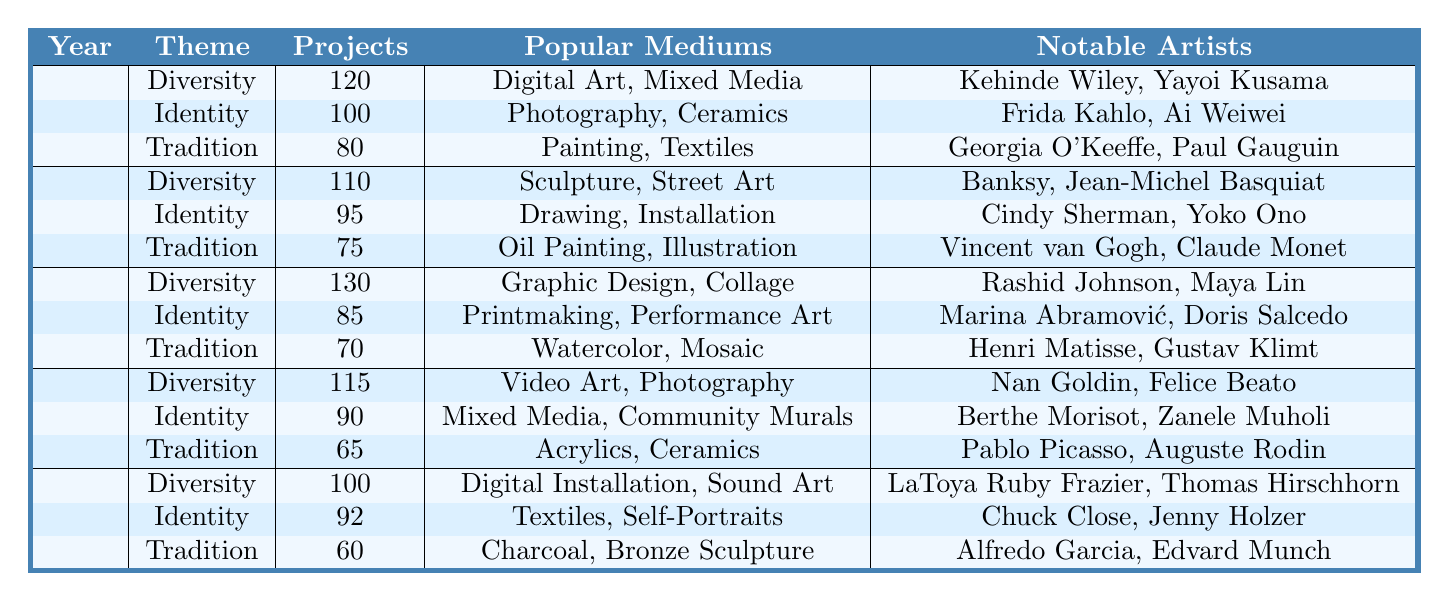What cultural theme had the most projects in 2023? In 2023, the table shows that the Diversity theme has 120 projects, which is more than Identity (100) and Tradition (80).
Answer: Diversity What is the total number of projects dedicated to the Identity theme from 2019 to 2023? Summing the Identity projects over the years: 92 (2019) + 90 (2020) + 85 (2021) + 95 (2022) + 100 (2023) = 462.
Answer: 462 Was there an increase in the number of Diversity projects from 2019 to 2023? In 2019, there were 100 Diversity projects, and in 2023, there were 120 projects. Since 120 is greater than 100, there was an increase.
Answer: Yes Which year had the least number of Tradition projects? Looking at the Tradition projects data, we see 60 (2019), 65 (2020), 70 (2021), 75 (2022), and 80 (2023). The least is 60 in 2019.
Answer: 2019 What was the average number of projects for the Tradition theme over the last five years? The total for Tradition projects is 60 + 65 + 70 + 75 + 80 = 350. There are 5 years, so the average is 350/5 = 70.
Answer: 70 How many more projects did the Diversity theme have than the Tradition theme in 2021? In 2021, Diversity had 130 projects and Tradition had 70 projects. The difference is 130 - 70 = 60.
Answer: 60 Which mediums were popular for Identity projects in 2022? The table indicates that in 2022, the popular mediums for Identity projects were Drawing and Installation.
Answer: Drawing, Installation What notable artists were featured in Diversity projects in 2020? According to the table, the notable artists for Diversity projects in 2020 were Nan Goldin and Felice Beato.
Answer: Nan Goldin, Felice Beato In which year did the Identity theme see its maximum number of projects? The Identity theme had 100 projects in 2023, which is more than the other years: 92 (2019), 90 (2020), 85 (2021), and 95 (2022).
Answer: 2023 Is the total number of Diversity projects from 2019 to 2021 greater than the total from 2022 to 2023? The total for Diversity from 2019 to 2021 is 100 + 115 + 130 = 345, and from 2022 to 2023 is 110 + 120 = 230. Since 345 is greater than 230, the statement is true.
Answer: Yes 